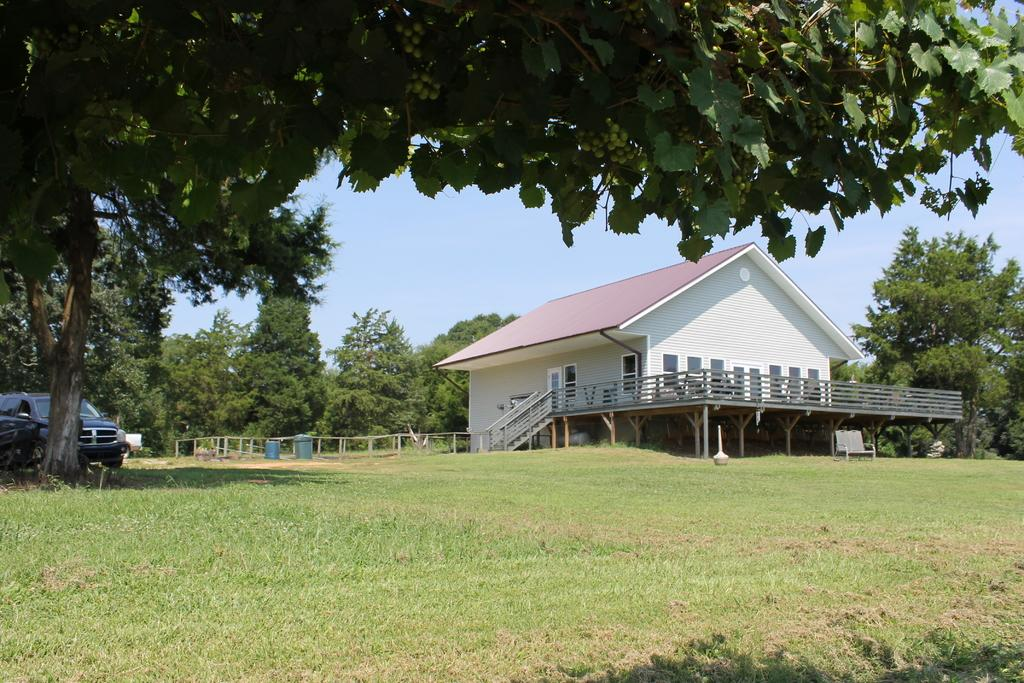What type of structure is visible in the image? There is a house in the image. What can be seen near the house? There is a railing and trees in the image. What is the ground covered with? The land is covered with grass. What type of seating is present in the image? There is a chair in the image. What mode of transportation is visible? There is a vehicle in the image. What part of the natural environment is visible in the image? The sky is visible in the image. Can you describe any other objects in the image? There are objects in the image, but their specific details are not mentioned in the facts. Is there a group of people enjoying a winter activity in the image? There is no mention of a group of people or winter activity in the image. 